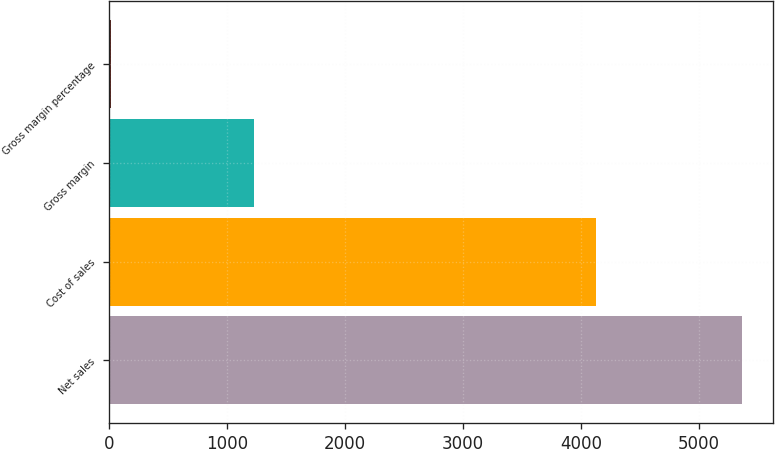<chart> <loc_0><loc_0><loc_500><loc_500><bar_chart><fcel>Net sales<fcel>Cost of sales<fcel>Gross margin<fcel>Gross margin percentage<nl><fcel>5363<fcel>4128<fcel>1235<fcel>23<nl></chart> 